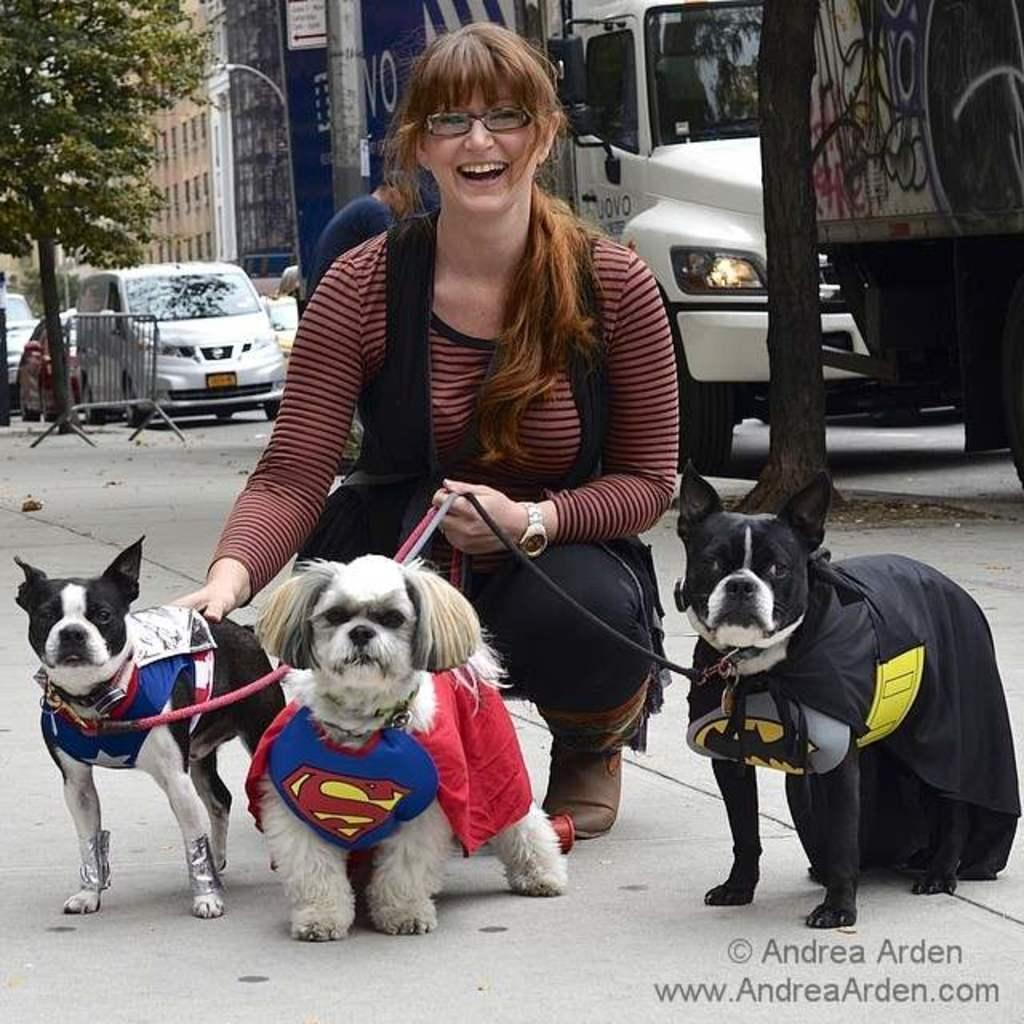Who is the main subject in the image? There is a lady in the image. What is the lady holding in the image? The lady is holding three dogs. How are the dogs dressed in the image? The dogs are dressed as superheroes. Where was the picture taken? The picture was taken on a road. What type of parcel is the lady holding in the image? There is no parcel visible in the image; the lady is holding three dogs dressed as superheroes. Can you tell me how many firemen are present in the image? There are no firemen present in the image; the main subjects are a lady and three dogs dressed as superheroes. 